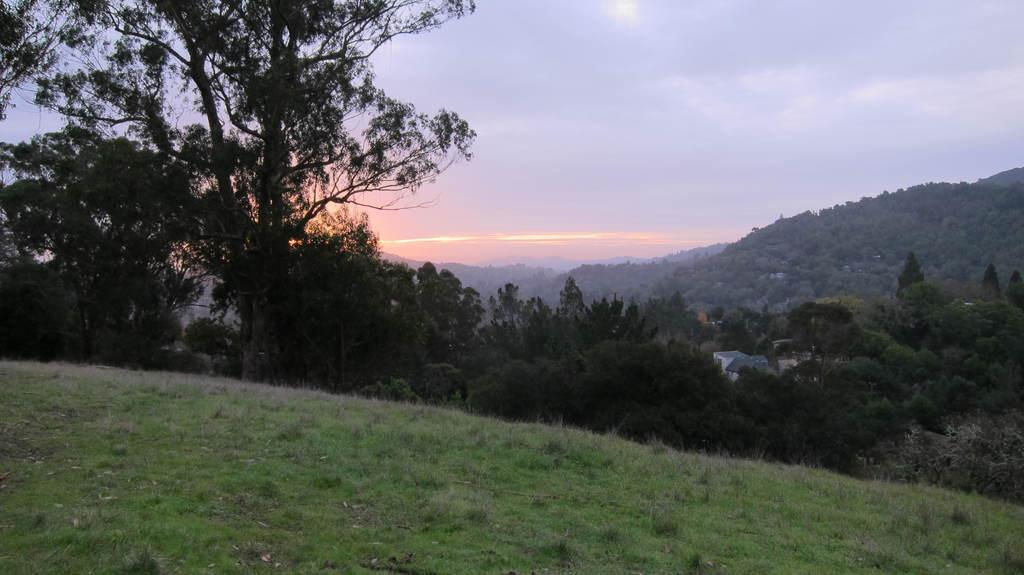What type of landscape is depicted in the image? The image features grassland and trees. Are there any structures visible in the image? Yes, there are houses in the image. What geographical features can be seen in the image? There are hills in the image. What is the source of light in the image? The sunlight is visible in the image. What is the condition of the sky in the background? The sky in the background is cloudy. What type of metal treatment is being applied to the pig in the image? There is no pig or metal treatment present in the image. 